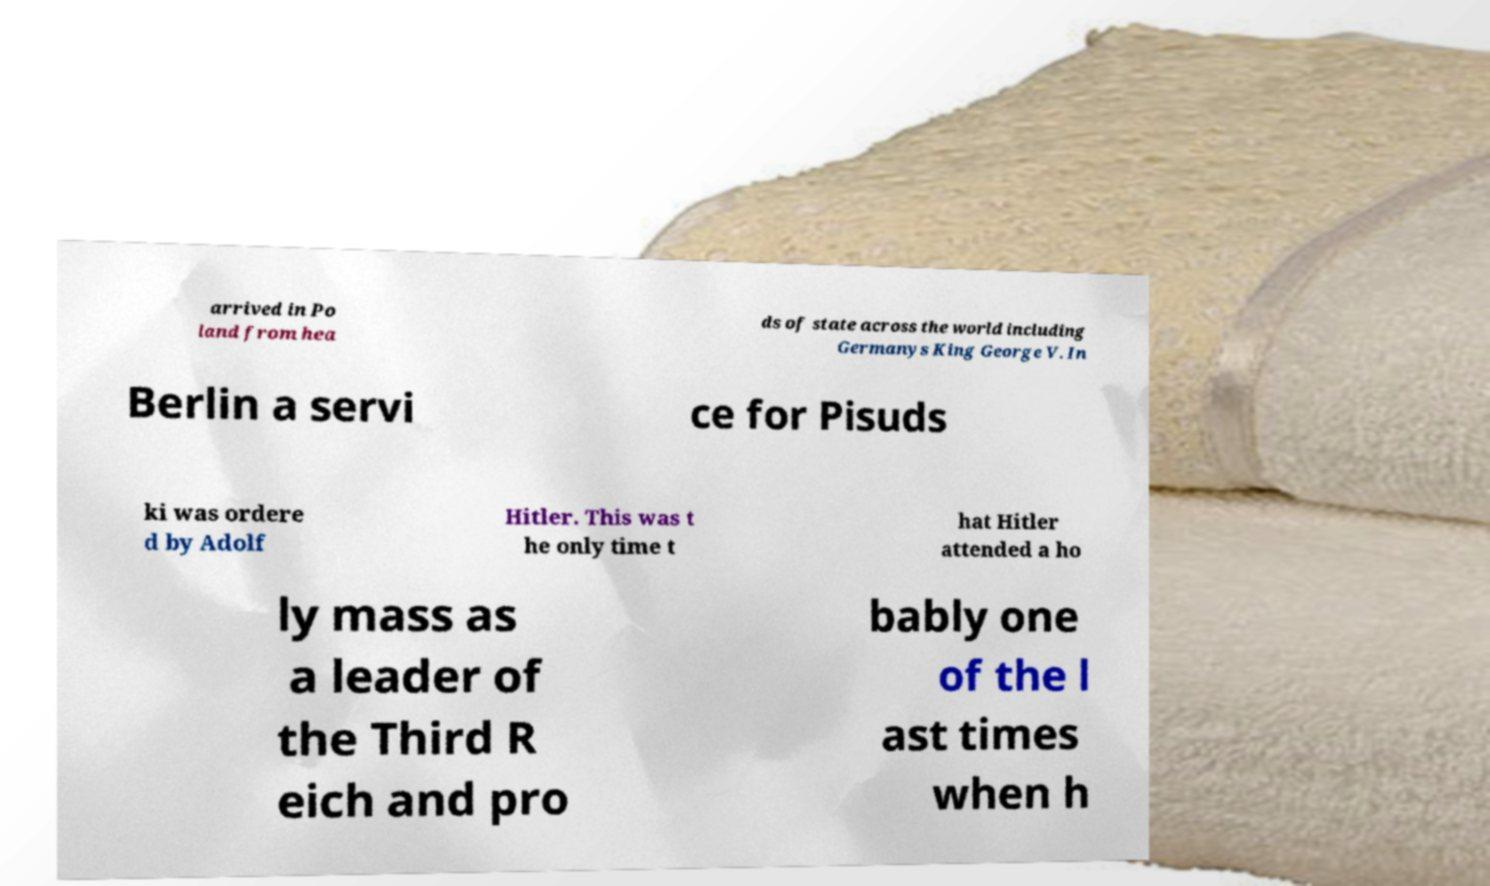Could you extract and type out the text from this image? arrived in Po land from hea ds of state across the world including Germanys King George V. In Berlin a servi ce for Pisuds ki was ordere d by Adolf Hitler. This was t he only time t hat Hitler attended a ho ly mass as a leader of the Third R eich and pro bably one of the l ast times when h 